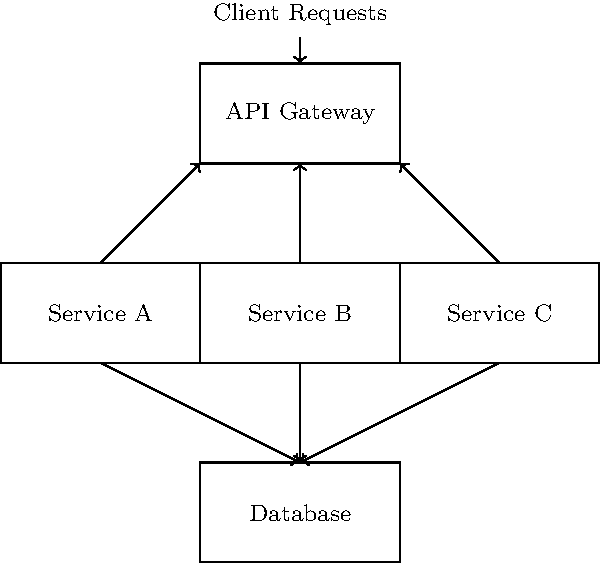In the given microservices architecture diagram, which component acts as the single entry point for all client requests and how does it contribute to the overall system design? To answer this question, let's analyze the diagram step-by-step:

1. Observe the overall structure: The diagram shows a typical microservices architecture with multiple components.

2. Identify the topmost component: The component at the top of the diagram is labeled "API Gateway".

3. Notice the incoming arrow: There's an arrow labeled "Client Requests" pointing to the API Gateway, indicating that all client requests enter the system through this component.

4. Examine the connections: The API Gateway is connected to three services (Service A, B, and C) below it.

5. Understand the API Gateway's role:
   a) It acts as a single entry point for all client requests.
   b) It routes requests to appropriate microservices.
   c) It can handle cross-cutting concerns like authentication, logging, and rate limiting.
   d) It simplifies the client-side code by providing a unified interface to multiple services.

6. Consider the benefits:
   a) Improved security by centralizing authentication and authorization.
   b) Better management of client-service interactions.
   c) Ability to handle protocol translation and API versioning.
   d) Potential for load balancing and caching at the gateway level.

Based on this analysis, we can conclude that the API Gateway is the component acting as the single entry point for all client requests, contributing significantly to the system's overall design and functionality.
Answer: API Gateway 